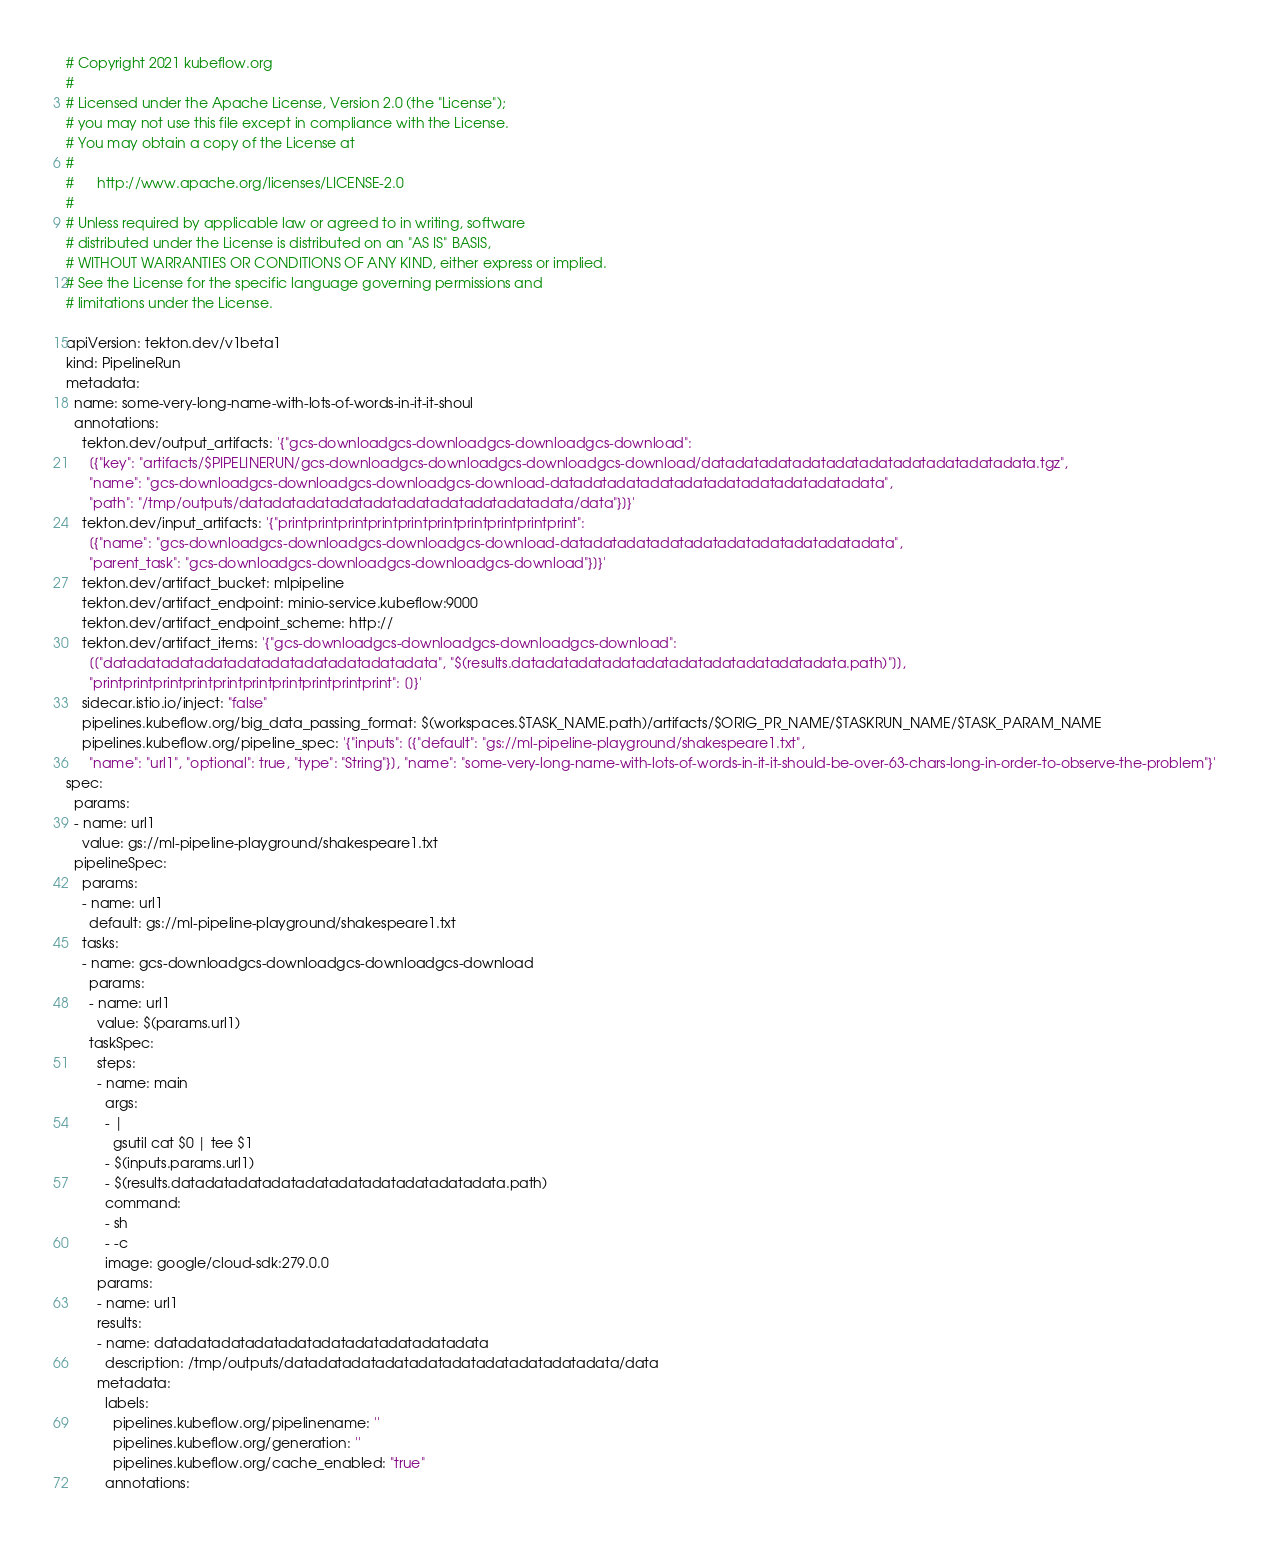Convert code to text. <code><loc_0><loc_0><loc_500><loc_500><_YAML_># Copyright 2021 kubeflow.org
#
# Licensed under the Apache License, Version 2.0 (the "License");
# you may not use this file except in compliance with the License.
# You may obtain a copy of the License at
#
#      http://www.apache.org/licenses/LICENSE-2.0
#
# Unless required by applicable law or agreed to in writing, software
# distributed under the License is distributed on an "AS IS" BASIS,
# WITHOUT WARRANTIES OR CONDITIONS OF ANY KIND, either express or implied.
# See the License for the specific language governing permissions and
# limitations under the License.

apiVersion: tekton.dev/v1beta1
kind: PipelineRun
metadata:
  name: some-very-long-name-with-lots-of-words-in-it-it-shoul
  annotations:
    tekton.dev/output_artifacts: '{"gcs-downloadgcs-downloadgcs-downloadgcs-download":
      [{"key": "artifacts/$PIPELINERUN/gcs-downloadgcs-downloadgcs-downloadgcs-download/datadatadatadatadatadatadatadatadatadata.tgz",
      "name": "gcs-downloadgcs-downloadgcs-downloadgcs-download-datadatadatadatadatadatadatadatadatadata",
      "path": "/tmp/outputs/datadatadatadatadatadatadatadatadatadata/data"}]}'
    tekton.dev/input_artifacts: '{"printprintprintprintprintprintprintprintprintprint":
      [{"name": "gcs-downloadgcs-downloadgcs-downloadgcs-download-datadatadatadatadatadatadatadatadatadata",
      "parent_task": "gcs-downloadgcs-downloadgcs-downloadgcs-download"}]}'
    tekton.dev/artifact_bucket: mlpipeline
    tekton.dev/artifact_endpoint: minio-service.kubeflow:9000
    tekton.dev/artifact_endpoint_scheme: http://
    tekton.dev/artifact_items: '{"gcs-downloadgcs-downloadgcs-downloadgcs-download":
      [["datadatadatadatadatadatadatadatadatadata", "$(results.datadatadatadatadatadatadatadatadatadata.path)"]],
      "printprintprintprintprintprintprintprintprintprint": []}'
    sidecar.istio.io/inject: "false"
    pipelines.kubeflow.org/big_data_passing_format: $(workspaces.$TASK_NAME.path)/artifacts/$ORIG_PR_NAME/$TASKRUN_NAME/$TASK_PARAM_NAME
    pipelines.kubeflow.org/pipeline_spec: '{"inputs": [{"default": "gs://ml-pipeline-playground/shakespeare1.txt",
      "name": "url1", "optional": true, "type": "String"}], "name": "some-very-long-name-with-lots-of-words-in-it-it-should-be-over-63-chars-long-in-order-to-observe-the-problem"}'
spec:
  params:
  - name: url1
    value: gs://ml-pipeline-playground/shakespeare1.txt
  pipelineSpec:
    params:
    - name: url1
      default: gs://ml-pipeline-playground/shakespeare1.txt
    tasks:
    - name: gcs-downloadgcs-downloadgcs-downloadgcs-download
      params:
      - name: url1
        value: $(params.url1)
      taskSpec:
        steps:
        - name: main
          args:
          - |
            gsutil cat $0 | tee $1
          - $(inputs.params.url1)
          - $(results.datadatadatadatadatadatadatadatadatadata.path)
          command:
          - sh
          - -c
          image: google/cloud-sdk:279.0.0
        params:
        - name: url1
        results:
        - name: datadatadatadatadatadatadatadatadatadata
          description: /tmp/outputs/datadatadatadatadatadatadatadatadatadata/data
        metadata:
          labels:
            pipelines.kubeflow.org/pipelinename: ''
            pipelines.kubeflow.org/generation: ''
            pipelines.kubeflow.org/cache_enabled: "true"
          annotations:</code> 